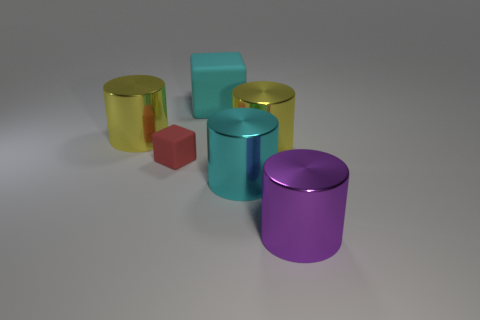Are these objects arranged in a pattern or randomly? The objects seem to be placed arbitrarily rather than in a deliberate pattern. They are spread out across a flat surface without a clear order or structure. 